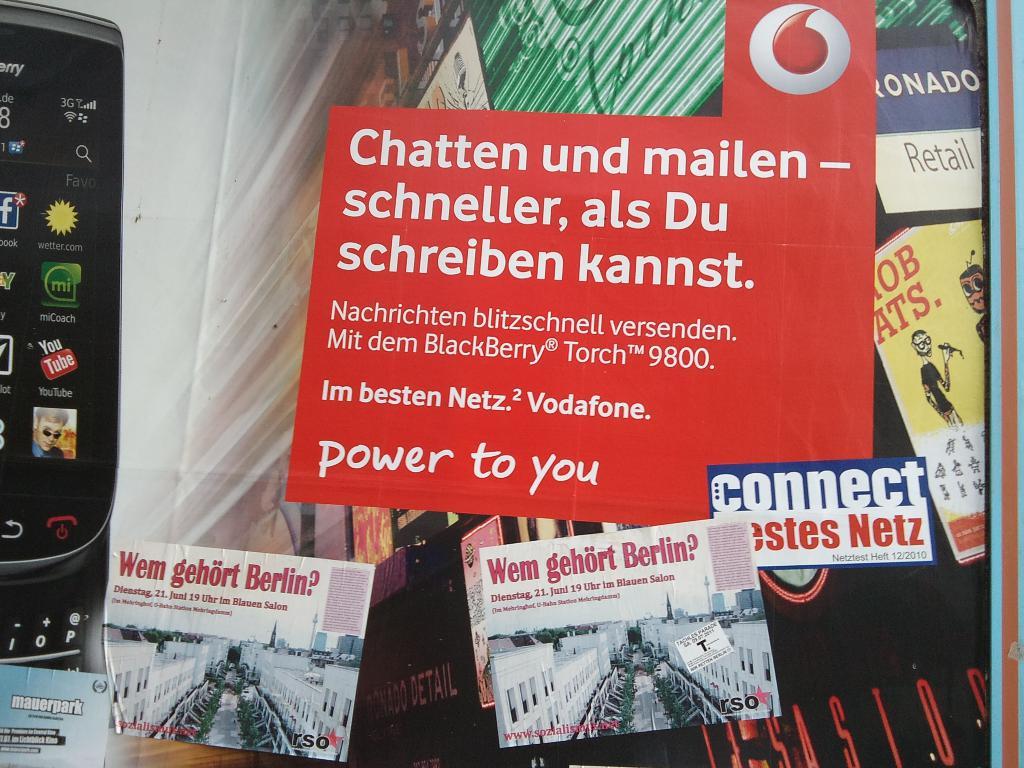Power to who?
Give a very brief answer. You. What is the first sentence on the red sign?
Give a very brief answer. Chatten und mailen. 